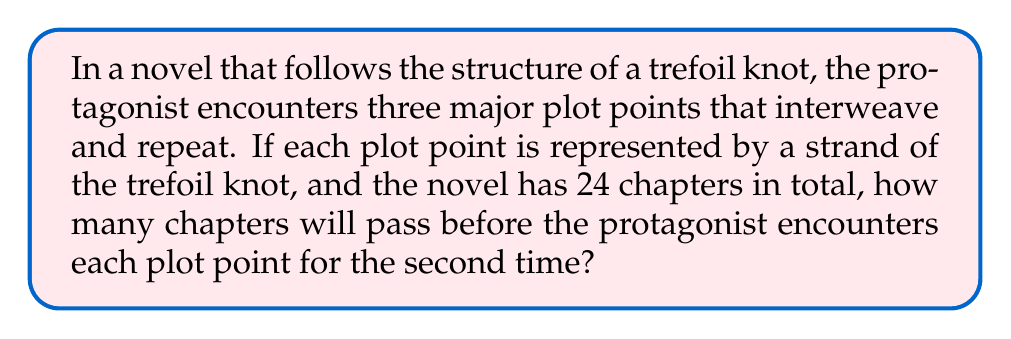Give your solution to this math problem. To solve this problem, we need to understand the structure of a trefoil knot and how it relates to storytelling:

1. A trefoil knot has three strands that interweave, each crossing over the others twice.

2. In storytelling terms, this means each plot point (represented by a strand) will appear, then reappear later in the story.

3. The trefoil knot completes one full rotation after six crossings.

4. In our novel structure, each crossing can be considered a chapter.

5. To calculate when each plot point reappears for the second time:
   - Divide the total number of chapters by the number of crossings in one rotation:
     $$ \frac{24 \text{ chapters}}{6 \text{ crossings per rotation}} = 4 \text{ rotations} $$

6. In one rotation (6 chapters), each plot point appears twice.

7. Therefore, to reach the second appearance of each plot point, we need:
   $$ 6 \text{ chapters} \times 2 = 12 \text{ chapters} $$

This means that after 12 chapters, the protagonist will have encountered each of the three major plot points for the second time.
Answer: 12 chapters 